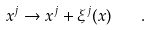Convert formula to latex. <formula><loc_0><loc_0><loc_500><loc_500>x ^ { j } \rightarrow x ^ { j } + \xi ^ { j } ( x ) \quad .</formula> 